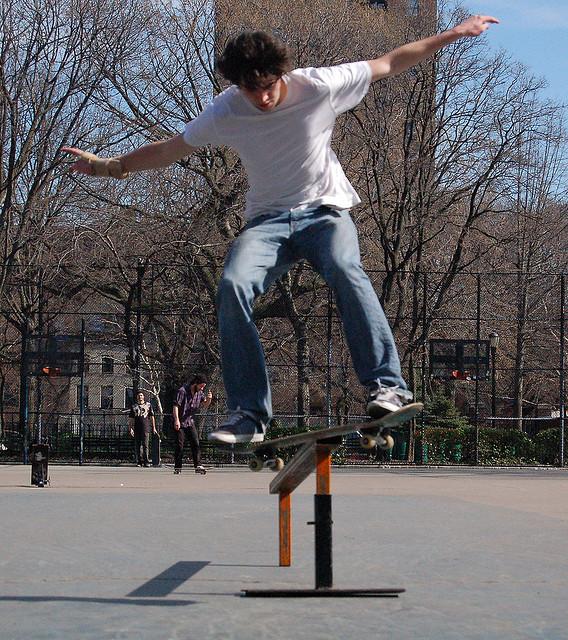Is the skateboarder doing a trick?
Be succinct. Yes. Do you think it would hurt if he fell?
Quick response, please. Yes. Are the trees bare?
Concise answer only. Yes. 